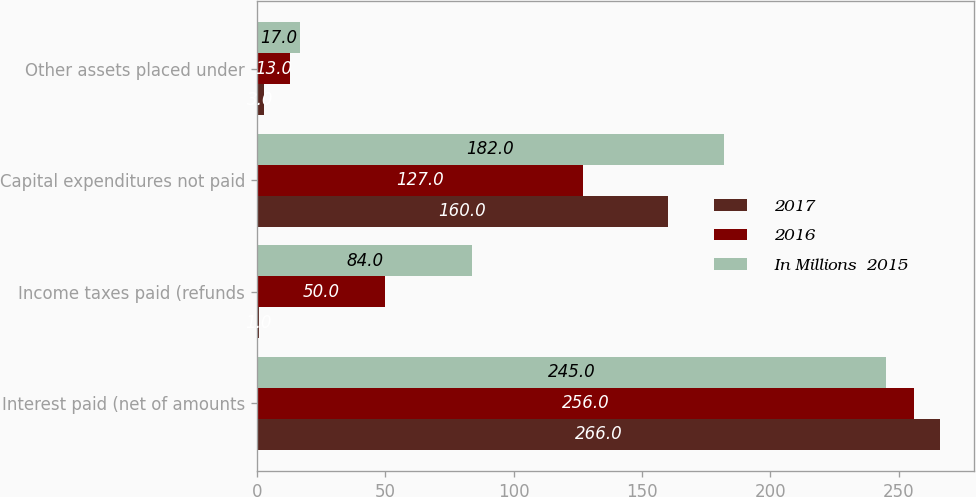Convert chart to OTSL. <chart><loc_0><loc_0><loc_500><loc_500><stacked_bar_chart><ecel><fcel>Interest paid (net of amounts<fcel>Income taxes paid (refunds<fcel>Capital expenditures not paid<fcel>Other assets placed under<nl><fcel>2017<fcel>266<fcel>1<fcel>160<fcel>3<nl><fcel>2016<fcel>256<fcel>50<fcel>127<fcel>13<nl><fcel>In Millions  2015<fcel>245<fcel>84<fcel>182<fcel>17<nl></chart> 